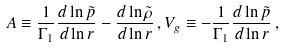<formula> <loc_0><loc_0><loc_500><loc_500>A \equiv \frac { 1 } { \Gamma _ { 1 } } \frac { d \ln \tilde { p } } { d \ln r } - \frac { d \ln \tilde { \rho } } { d \ln r } \, , V _ { g } \equiv - \frac { 1 } { \Gamma _ { 1 } } \frac { d \ln \tilde { p } } { d \ln r } \, ,</formula> 